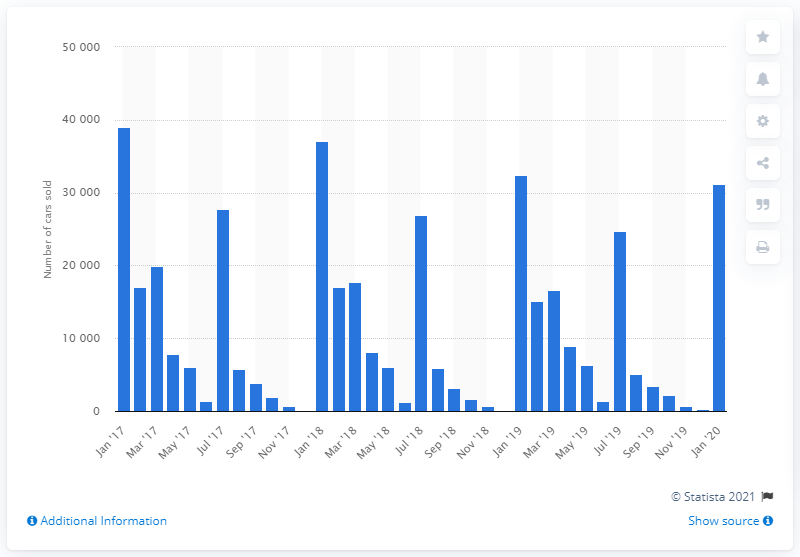Identify some key points in this picture. In January 2018, a total of 37,034 units were sold. In January 2017, a total of 39,003 cars were sold in Ireland. 